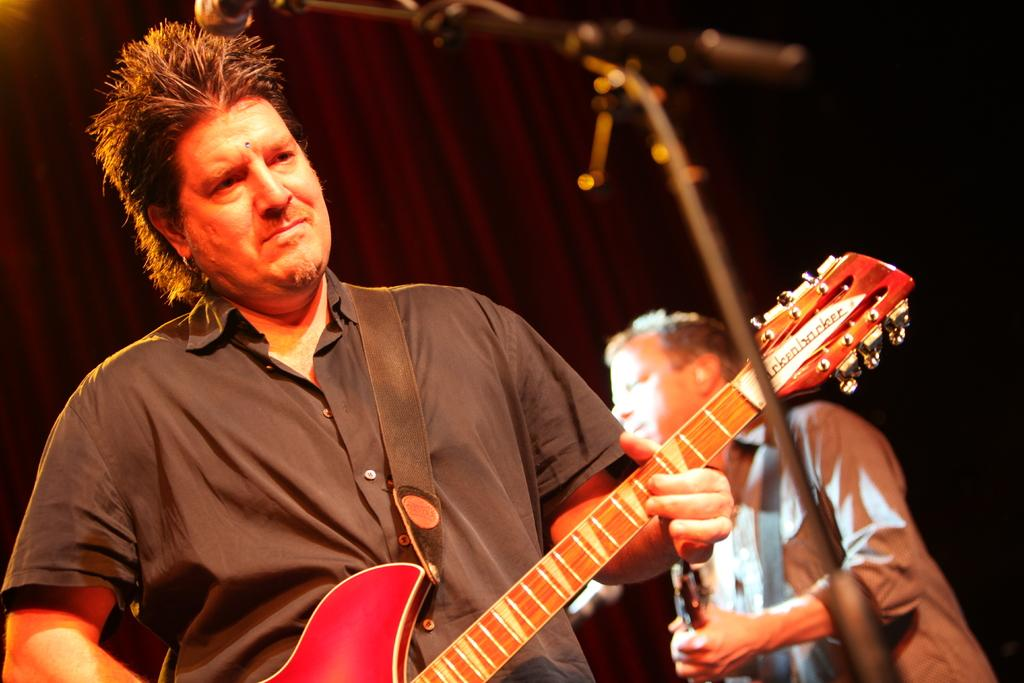How many people are in the image? There are two people in the image. What are the people doing in the image? The people are standing and holding guitars. What object is present for amplifying sound in the image? There is a microphone on a stand in the image. What can be seen in the background of the image? There is a curtain in the background of the image. What type of box can be seen in the image? There is no box present in the image. 